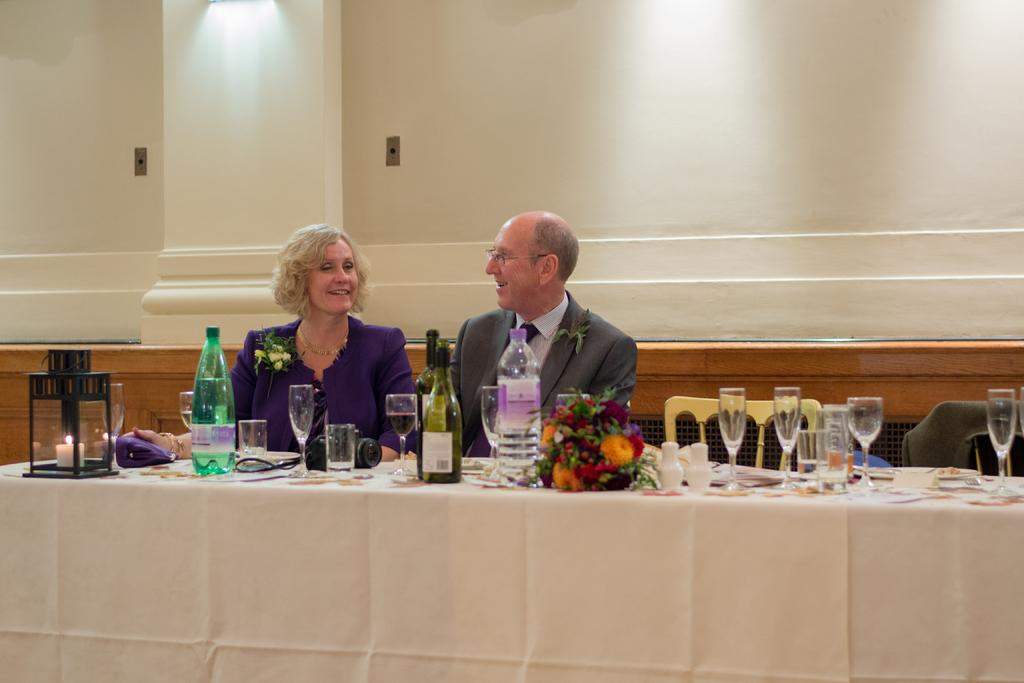How many people are in the image? There are two persons in the image. What are the two persons doing in the image? The two persons are sitting in front of a table. What objects can be seen on the table? There are bottles and glasses on the table. What type of paper is being used as bait in the image? There is no paper or bait present in the image. 